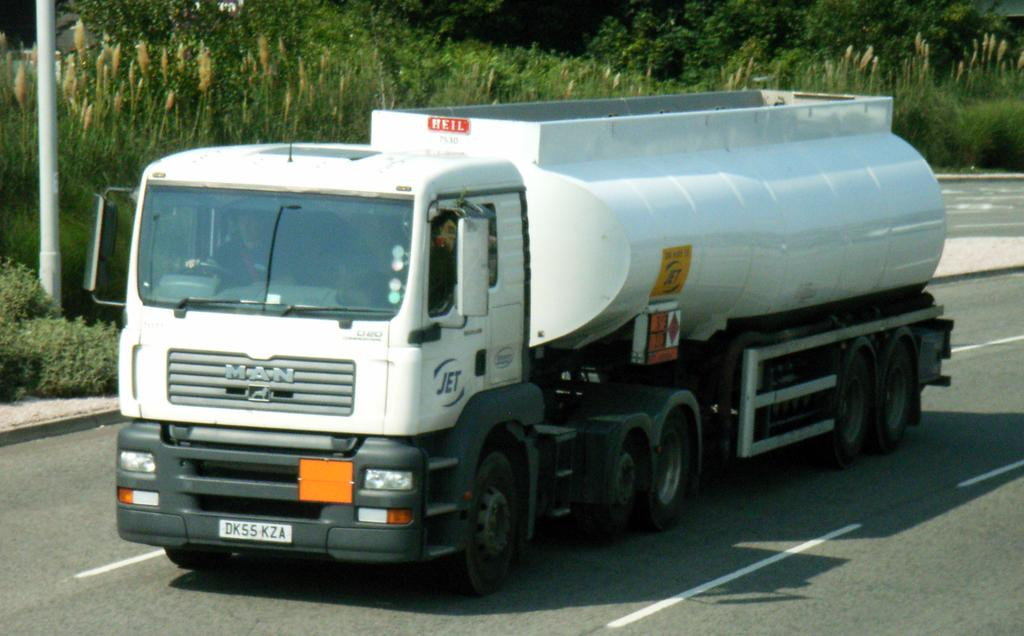What is on the road in the image? There is a vehicle on the road in the image. What can be seen in the background of the image? There are trees, plants, and a pole in the background of the image. What type of lipstick is the vehicle wearing in the image? There is no lipstick or any indication of cosmetics in the image; it features a vehicle on the road and various elements in the background. 